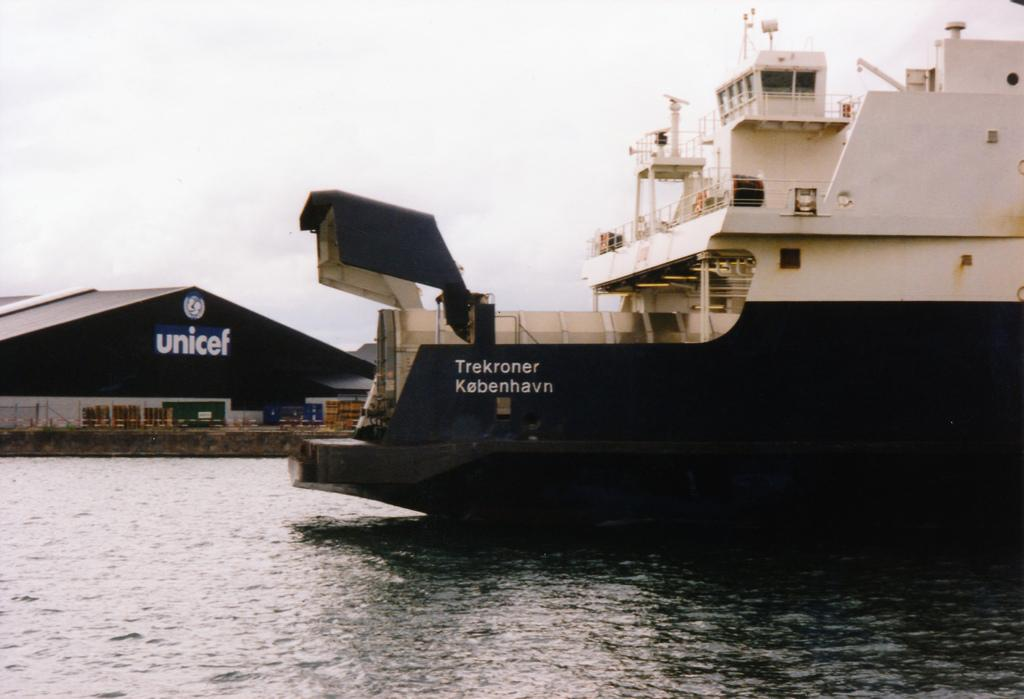<image>
Provide a brief description of the given image. A large boat is docked in the water, in front of a Unicef building. 